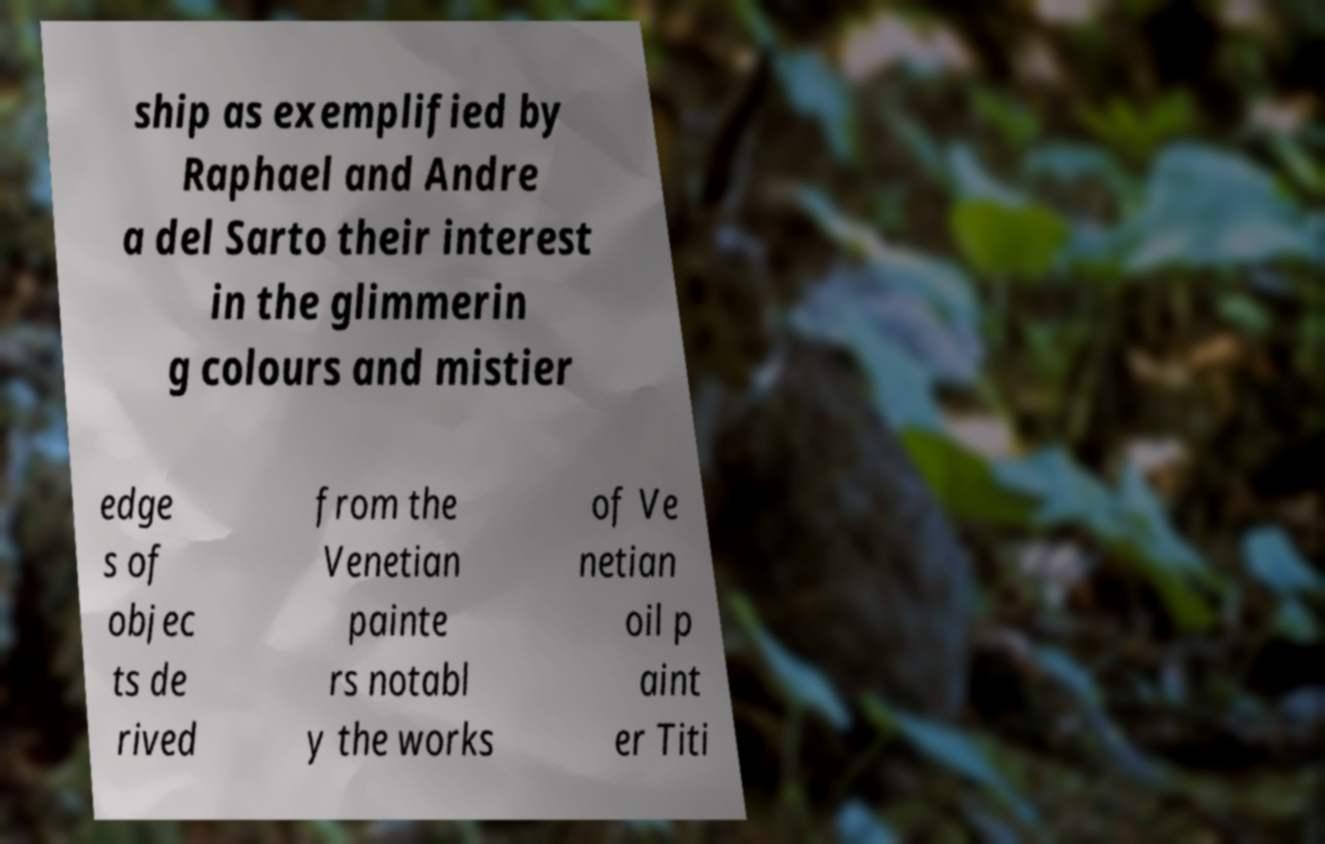What messages or text are displayed in this image? I need them in a readable, typed format. ship as exemplified by Raphael and Andre a del Sarto their interest in the glimmerin g colours and mistier edge s of objec ts de rived from the Venetian painte rs notabl y the works of Ve netian oil p aint er Titi 